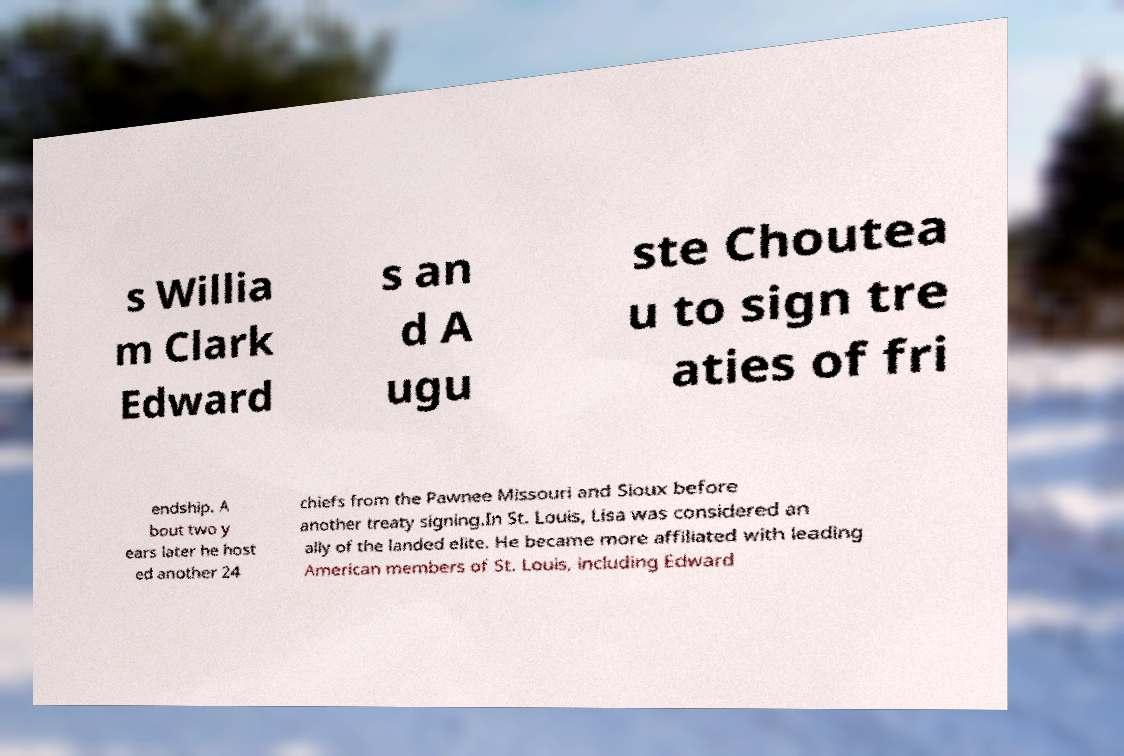I need the written content from this picture converted into text. Can you do that? s Willia m Clark Edward s an d A ugu ste Choutea u to sign tre aties of fri endship. A bout two y ears later he host ed another 24 chiefs from the Pawnee Missouri and Sioux before another treaty signing.In St. Louis, Lisa was considered an ally of the landed elite. He became more affiliated with leading American members of St. Louis, including Edward 